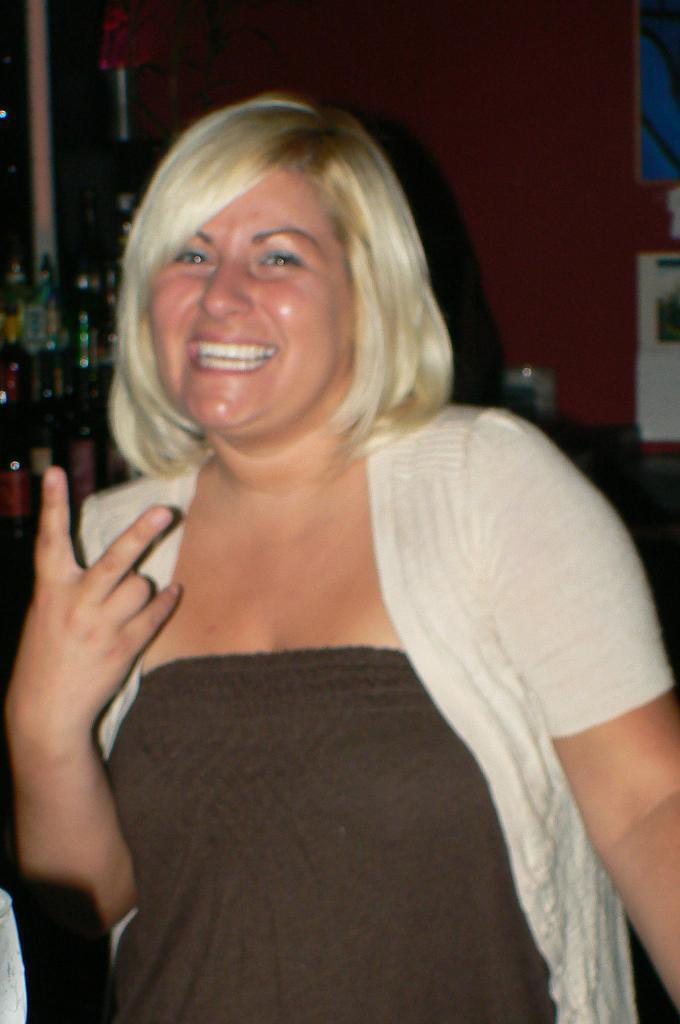Could you give a brief overview of what you see in this image? In the middle of the image a woman is standing and smiling. Behind her we can see some products. At the top of the image we can see a wall. 